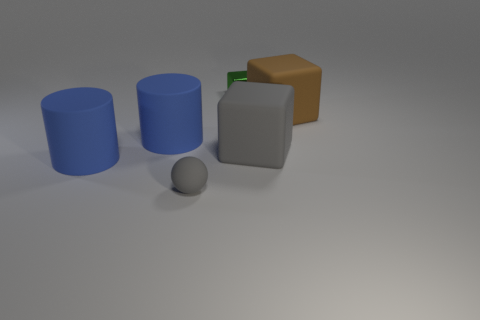Subtract all rubber cubes. How many cubes are left? 1 Add 1 yellow metallic cubes. How many objects exist? 7 Subtract all yellow blocks. Subtract all brown cylinders. How many blocks are left? 3 Subtract all spheres. How many objects are left? 5 Add 3 metal cubes. How many metal cubes exist? 4 Subtract 1 brown blocks. How many objects are left? 5 Subtract all brown blocks. Subtract all blue rubber objects. How many objects are left? 3 Add 2 large gray things. How many large gray things are left? 3 